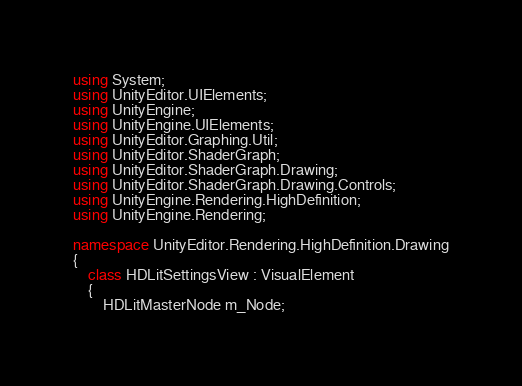<code> <loc_0><loc_0><loc_500><loc_500><_C#_>using System;
using UnityEditor.UIElements;
using UnityEngine;
using UnityEngine.UIElements;
using UnityEditor.Graphing.Util;
using UnityEditor.ShaderGraph;
using UnityEditor.ShaderGraph.Drawing;
using UnityEditor.ShaderGraph.Drawing.Controls;
using UnityEngine.Rendering.HighDefinition;
using UnityEngine.Rendering;

namespace UnityEditor.Rendering.HighDefinition.Drawing
{
    class HDLitSettingsView : VisualElement
    {
        HDLitMasterNode m_Node;
</code> 